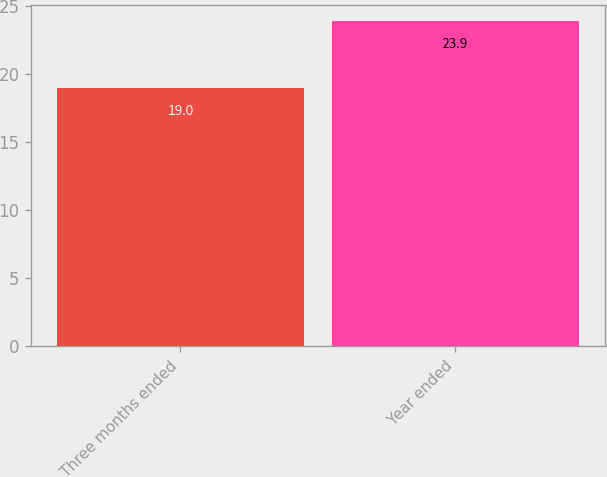Convert chart. <chart><loc_0><loc_0><loc_500><loc_500><bar_chart><fcel>Three months ended<fcel>Year ended<nl><fcel>19<fcel>23.9<nl></chart> 